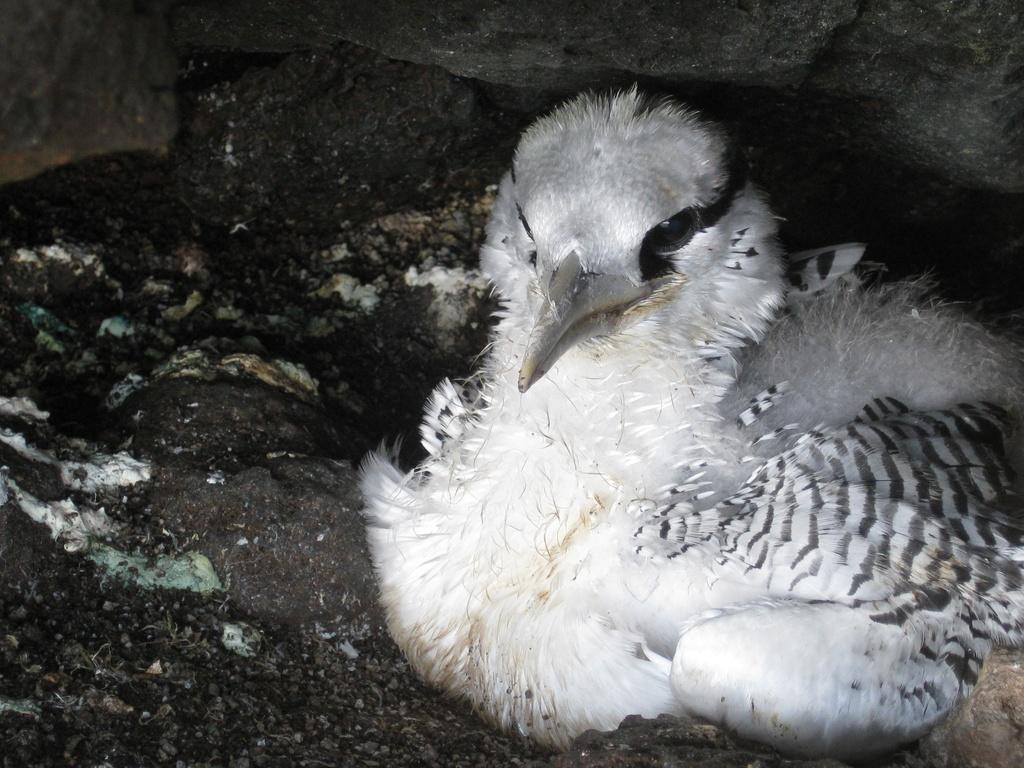What type of animal is present in the image? There is a bird in the image. What is the bird doing in the image? The bird is sitting on the surface. Where is the bird located in relation to the rock? The bird is beneath a rock. What type of vehicle can be seen driving in the image? There is no vehicle present in the image, and therefore no driving activity can be observed. What type of furniture is visible in the bedroom in the image? There is no bedroom or furniture present in the image. What type of book is the bird reading in the image? There is no book present in the image, and the bird is not shown reading anything. 